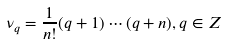Convert formula to latex. <formula><loc_0><loc_0><loc_500><loc_500>\nu _ { q } = \frac { 1 } { n ! } ( q + 1 ) \cdots ( q + n ) , q \in Z</formula> 